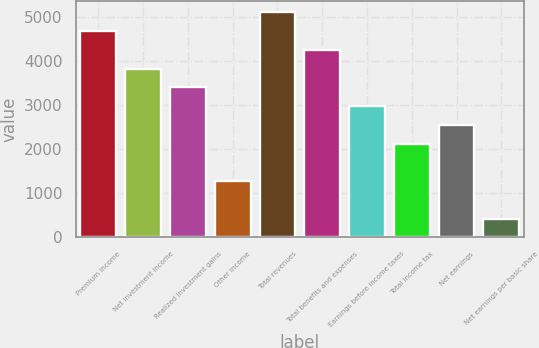<chart> <loc_0><loc_0><loc_500><loc_500><bar_chart><fcel>Premium income<fcel>Net investment income<fcel>Realized investment gains<fcel>Other income<fcel>Total revenues<fcel>Total benefits and expenses<fcel>Earnings before income taxes<fcel>Total income tax<fcel>Net earnings<fcel>Net earnings per basic share<nl><fcel>4686.02<fcel>3834.06<fcel>3408.08<fcel>1278.18<fcel>5112<fcel>4260.04<fcel>2982.1<fcel>2130.14<fcel>2556.12<fcel>426.22<nl></chart> 